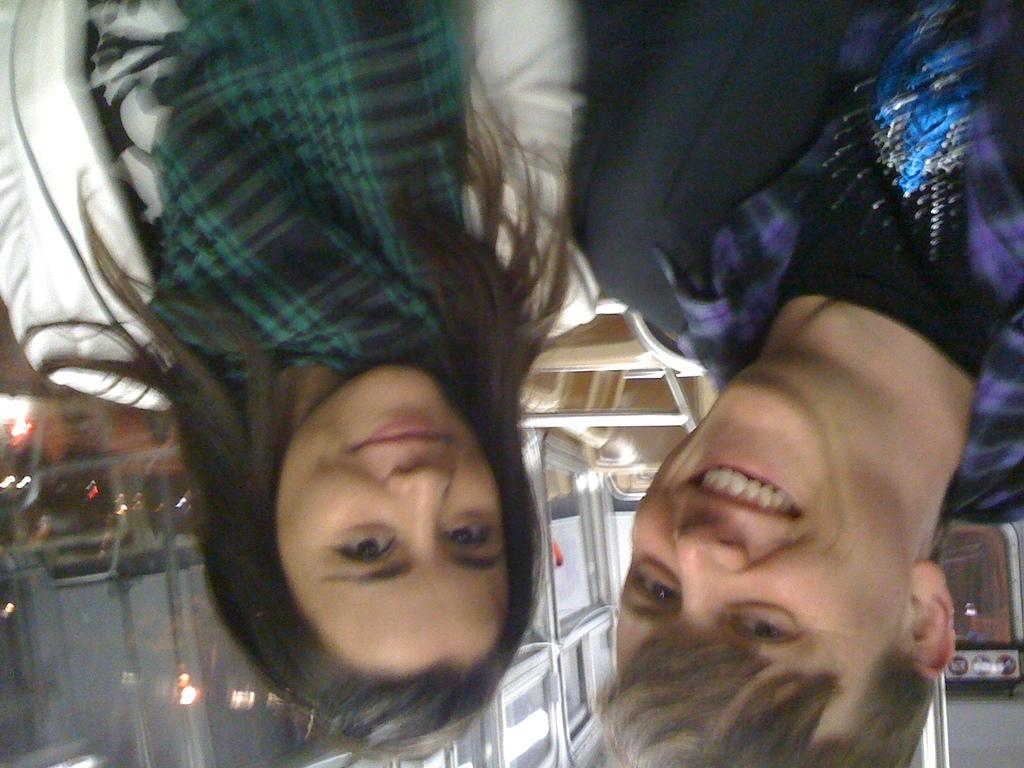How many people are in the image? There are two persons in the image. What is the facial expression of the persons in the image? The persons are smiling. What can be seen in the background of the image? There are lights and objects in the background of the image. What type of pump is visible in the image? There is no pump present in the image. How old is the daughter in the image? There is no daughter present in the image. 